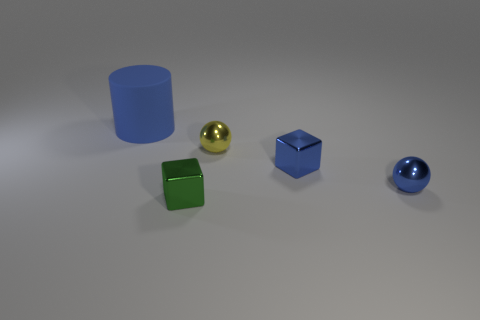Subtract 1 blocks. How many blocks are left? 1 Add 4 large cylinders. How many large cylinders exist? 5 Add 4 small green metallic blocks. How many objects exist? 9 Subtract 0 cyan cylinders. How many objects are left? 5 Subtract all blocks. How many objects are left? 3 Subtract all gray spheres. Subtract all green cubes. How many spheres are left? 2 Subtract all red spheres. How many green blocks are left? 1 Subtract all blue metallic balls. Subtract all metal cubes. How many objects are left? 2 Add 2 small green metal blocks. How many small green metal blocks are left? 3 